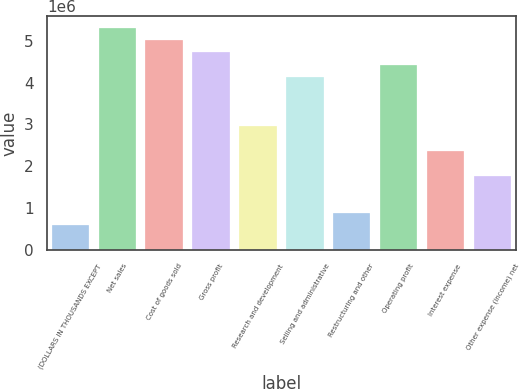Convert chart to OTSL. <chart><loc_0><loc_0><loc_500><loc_500><bar_chart><fcel>(DOLLARS IN THOUSANDS EXCEPT<fcel>Net sales<fcel>Cost of goods sold<fcel>Gross profit<fcel>Research and development<fcel>Selling and administrative<fcel>Restructuring and other<fcel>Operating profit<fcel>Interest expense<fcel>Other expense (income) net<nl><fcel>590583<fcel>5.31521e+06<fcel>5.01992e+06<fcel>4.72463e+06<fcel>2.9529e+06<fcel>4.13405e+06<fcel>885872<fcel>4.42934e+06<fcel>2.36232e+06<fcel>1.77174e+06<nl></chart> 